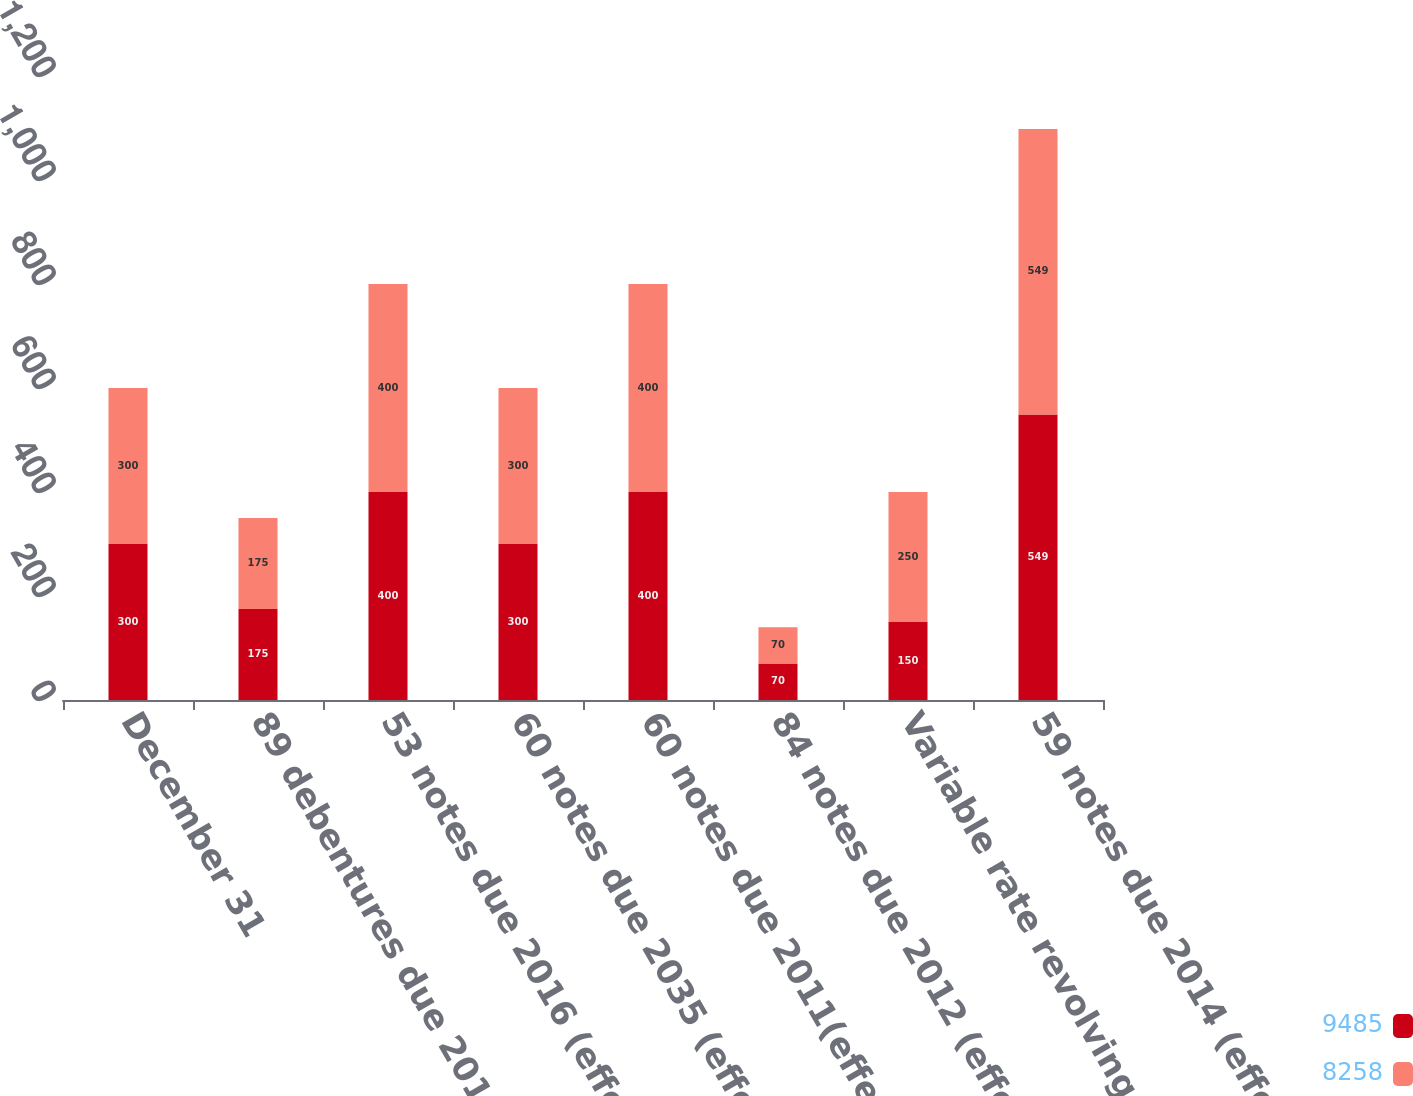Convert chart. <chart><loc_0><loc_0><loc_500><loc_500><stacked_bar_chart><ecel><fcel>December 31<fcel>89 debentures due 2011<fcel>53 notes due 2016 (effective<fcel>60 notes due 2035 (effective<fcel>60 notes due 2011(effective<fcel>84 notes due 2012 (effective<fcel>Variable rate revolving credit<fcel>59 notes due 2014 (effective<nl><fcel>9485<fcel>300<fcel>175<fcel>400<fcel>300<fcel>400<fcel>70<fcel>150<fcel>549<nl><fcel>8258<fcel>300<fcel>175<fcel>400<fcel>300<fcel>400<fcel>70<fcel>250<fcel>549<nl></chart> 